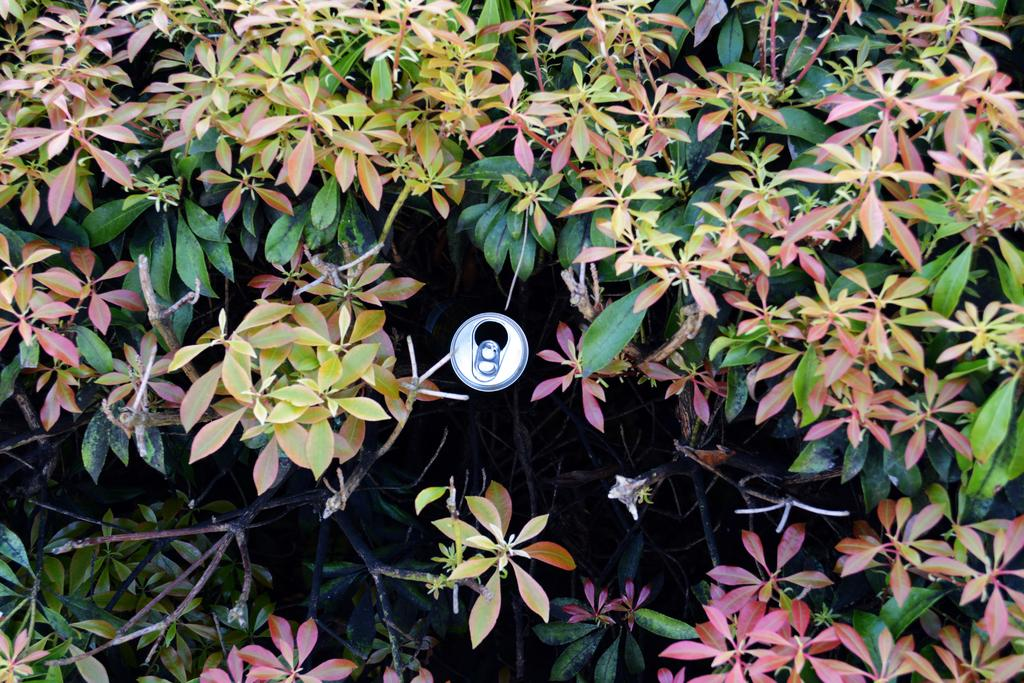What object is in the image? There is a tin in the image. What can be seen around the tin in the image? Trees are present around the tin in the image. How much did the person pay for the elbow in the image? There is no mention of a payment or an elbow in the image; it only features a tin and trees. 